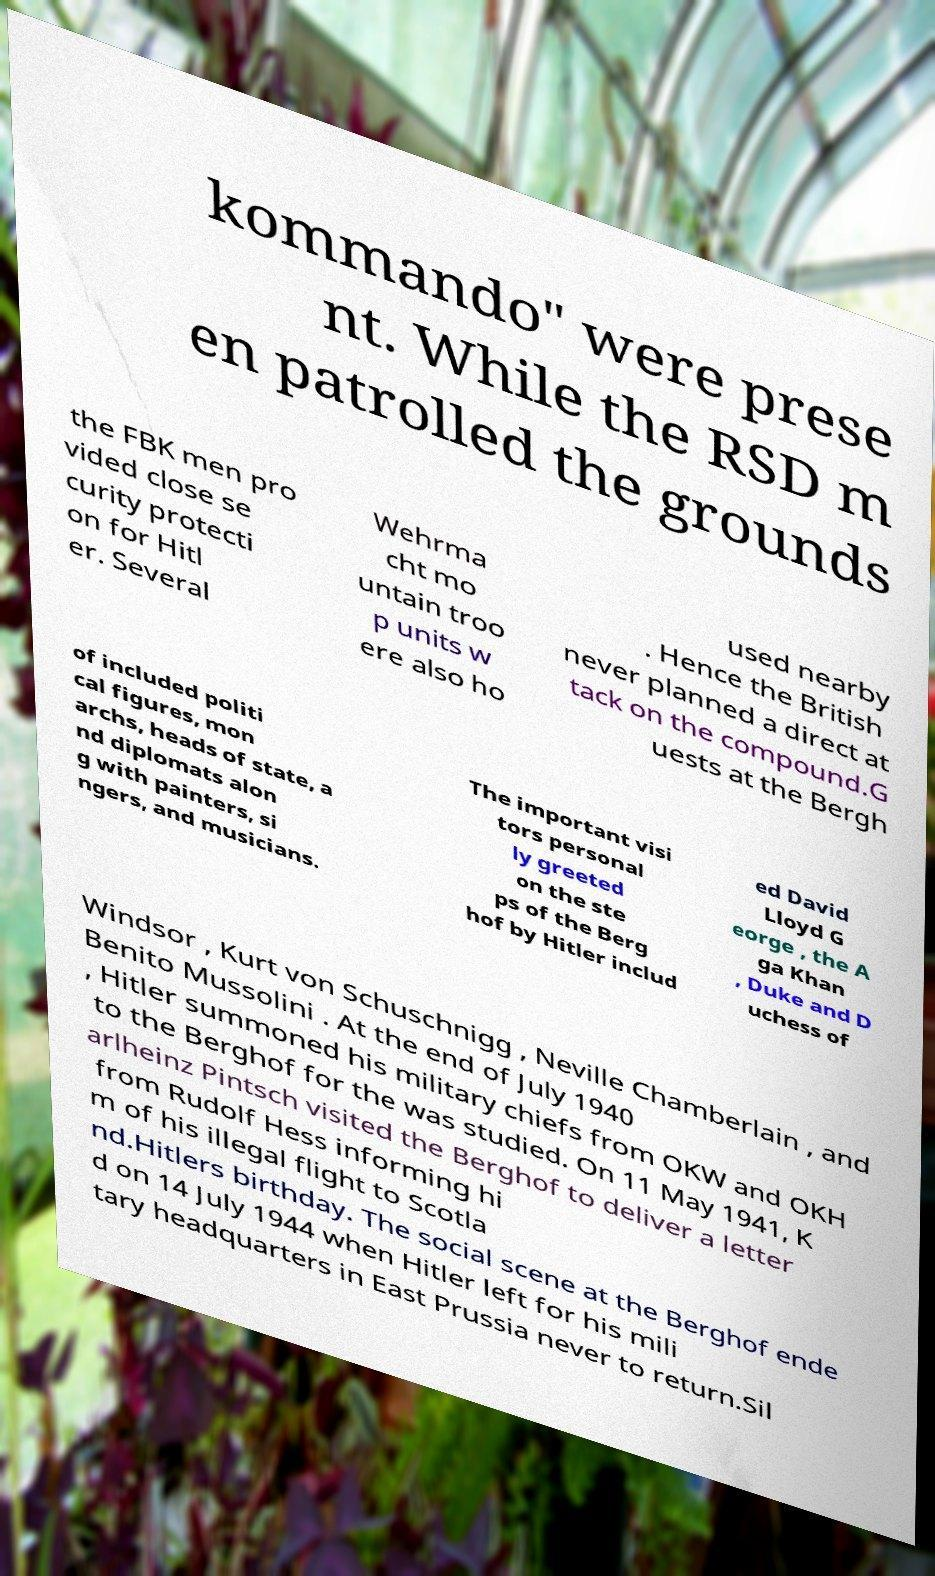Please identify and transcribe the text found in this image. kommando" were prese nt. While the RSD m en patrolled the grounds the FBK men pro vided close se curity protecti on for Hitl er. Several Wehrma cht mo untain troo p units w ere also ho used nearby . Hence the British never planned a direct at tack on the compound.G uests at the Bergh of included politi cal figures, mon archs, heads of state, a nd diplomats alon g with painters, si ngers, and musicians. The important visi tors personal ly greeted on the ste ps of the Berg hof by Hitler includ ed David Lloyd G eorge , the A ga Khan , Duke and D uchess of Windsor , Kurt von Schuschnigg , Neville Chamberlain , and Benito Mussolini . At the end of July 1940 , Hitler summoned his military chiefs from OKW and OKH to the Berghof for the was studied. On 11 May 1941, K arlheinz Pintsch visited the Berghof to deliver a letter from Rudolf Hess informing hi m of his illegal flight to Scotla nd.Hitlers birthday. The social scene at the Berghof ende d on 14 July 1944 when Hitler left for his mili tary headquarters in East Prussia never to return.Sil 